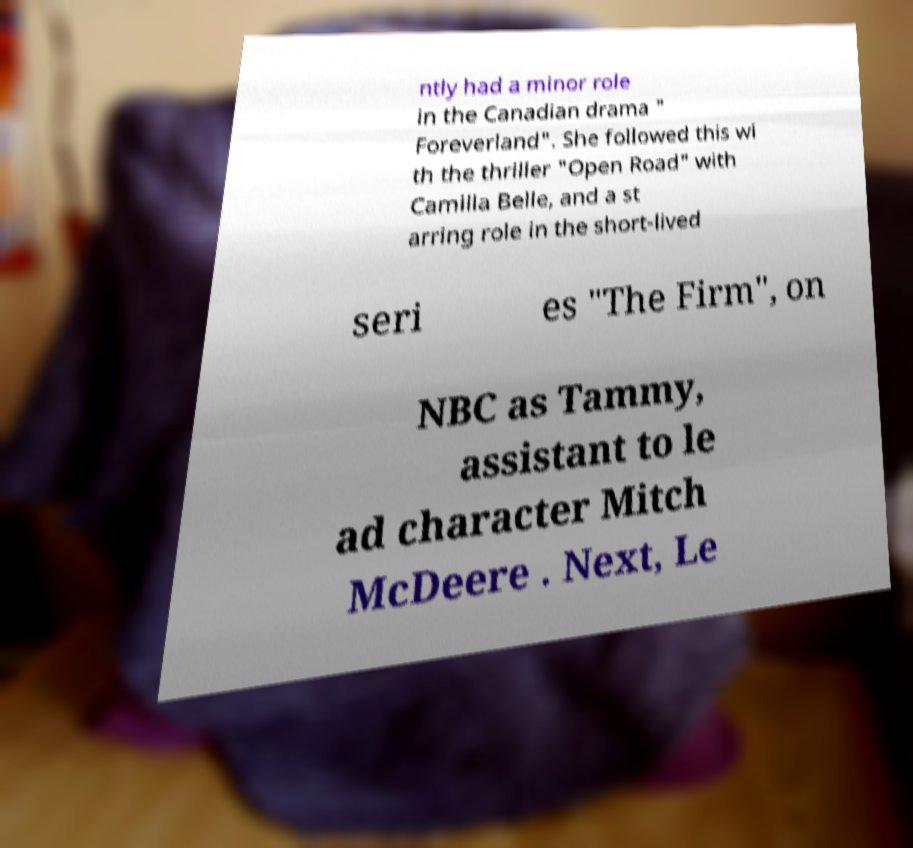Can you read and provide the text displayed in the image?This photo seems to have some interesting text. Can you extract and type it out for me? ntly had a minor role in the Canadian drama " Foreverland". She followed this wi th the thriller "Open Road" with Camilla Belle, and a st arring role in the short-lived seri es "The Firm", on NBC as Tammy, assistant to le ad character Mitch McDeere . Next, Le 